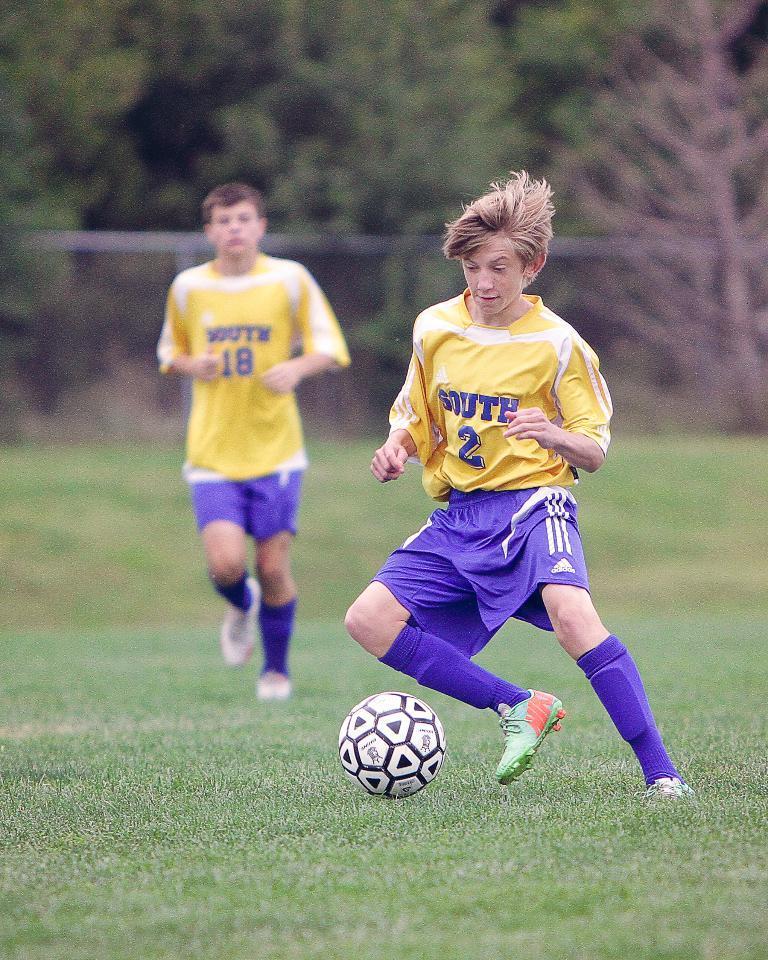Can you describe this image briefly? There are two men, with yellow color t-shirt and blue color pant. They are playing football on the ground. The men in the right side is kicking the ball with his right leg. In the background there are some tree. 